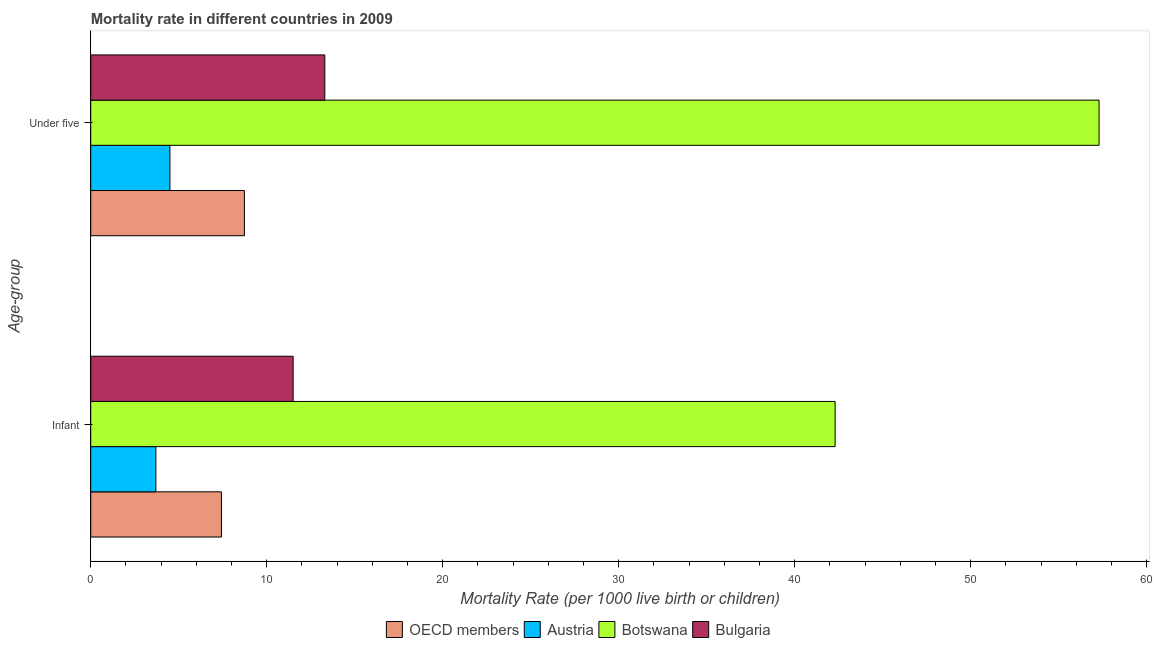Are the number of bars on each tick of the Y-axis equal?
Ensure brevity in your answer.  Yes. How many bars are there on the 2nd tick from the top?
Your response must be concise. 4. How many bars are there on the 1st tick from the bottom?
Provide a succinct answer. 4. What is the label of the 1st group of bars from the top?
Make the answer very short. Under five. Across all countries, what is the maximum under-5 mortality rate?
Give a very brief answer. 57.3. In which country was the under-5 mortality rate maximum?
Provide a succinct answer. Botswana. What is the total under-5 mortality rate in the graph?
Your answer should be compact. 83.83. What is the difference between the infant mortality rate in Austria and that in OECD members?
Make the answer very short. -3.73. What is the difference between the infant mortality rate in Bulgaria and the under-5 mortality rate in OECD members?
Provide a short and direct response. 2.77. What is the average infant mortality rate per country?
Your response must be concise. 16.23. What is the difference between the infant mortality rate and under-5 mortality rate in OECD members?
Ensure brevity in your answer.  -1.3. In how many countries, is the under-5 mortality rate greater than 34 ?
Your answer should be compact. 1. What is the ratio of the infant mortality rate in OECD members to that in Austria?
Offer a very short reply. 2.01. Is the under-5 mortality rate in Botswana less than that in OECD members?
Provide a succinct answer. No. In how many countries, is the under-5 mortality rate greater than the average under-5 mortality rate taken over all countries?
Provide a succinct answer. 1. What does the 3rd bar from the top in Infant represents?
Your answer should be compact. Austria. What does the 4th bar from the bottom in Infant represents?
Your answer should be very brief. Bulgaria. How many bars are there?
Provide a short and direct response. 8. How many countries are there in the graph?
Ensure brevity in your answer.  4. What is the difference between two consecutive major ticks on the X-axis?
Offer a very short reply. 10. Are the values on the major ticks of X-axis written in scientific E-notation?
Provide a succinct answer. No. Does the graph contain any zero values?
Your response must be concise. No. Does the graph contain grids?
Ensure brevity in your answer.  No. Where does the legend appear in the graph?
Offer a terse response. Bottom center. What is the title of the graph?
Ensure brevity in your answer.  Mortality rate in different countries in 2009. What is the label or title of the X-axis?
Make the answer very short. Mortality Rate (per 1000 live birth or children). What is the label or title of the Y-axis?
Offer a terse response. Age-group. What is the Mortality Rate (per 1000 live birth or children) of OECD members in Infant?
Give a very brief answer. 7.43. What is the Mortality Rate (per 1000 live birth or children) in Botswana in Infant?
Offer a very short reply. 42.3. What is the Mortality Rate (per 1000 live birth or children) in Bulgaria in Infant?
Your answer should be compact. 11.5. What is the Mortality Rate (per 1000 live birth or children) in OECD members in Under five?
Your answer should be compact. 8.73. What is the Mortality Rate (per 1000 live birth or children) of Austria in Under five?
Give a very brief answer. 4.5. What is the Mortality Rate (per 1000 live birth or children) in Botswana in Under five?
Your answer should be compact. 57.3. Across all Age-group, what is the maximum Mortality Rate (per 1000 live birth or children) of OECD members?
Give a very brief answer. 8.73. Across all Age-group, what is the maximum Mortality Rate (per 1000 live birth or children) of Austria?
Make the answer very short. 4.5. Across all Age-group, what is the maximum Mortality Rate (per 1000 live birth or children) in Botswana?
Offer a very short reply. 57.3. Across all Age-group, what is the minimum Mortality Rate (per 1000 live birth or children) of OECD members?
Offer a terse response. 7.43. Across all Age-group, what is the minimum Mortality Rate (per 1000 live birth or children) of Austria?
Offer a terse response. 3.7. Across all Age-group, what is the minimum Mortality Rate (per 1000 live birth or children) of Botswana?
Ensure brevity in your answer.  42.3. Across all Age-group, what is the minimum Mortality Rate (per 1000 live birth or children) of Bulgaria?
Your response must be concise. 11.5. What is the total Mortality Rate (per 1000 live birth or children) of OECD members in the graph?
Ensure brevity in your answer.  16.16. What is the total Mortality Rate (per 1000 live birth or children) in Botswana in the graph?
Give a very brief answer. 99.6. What is the total Mortality Rate (per 1000 live birth or children) of Bulgaria in the graph?
Make the answer very short. 24.8. What is the difference between the Mortality Rate (per 1000 live birth or children) of OECD members in Infant and that in Under five?
Offer a very short reply. -1.3. What is the difference between the Mortality Rate (per 1000 live birth or children) of Botswana in Infant and that in Under five?
Your answer should be compact. -15. What is the difference between the Mortality Rate (per 1000 live birth or children) in Bulgaria in Infant and that in Under five?
Keep it short and to the point. -1.8. What is the difference between the Mortality Rate (per 1000 live birth or children) of OECD members in Infant and the Mortality Rate (per 1000 live birth or children) of Austria in Under five?
Your answer should be compact. 2.93. What is the difference between the Mortality Rate (per 1000 live birth or children) of OECD members in Infant and the Mortality Rate (per 1000 live birth or children) of Botswana in Under five?
Your answer should be compact. -49.87. What is the difference between the Mortality Rate (per 1000 live birth or children) of OECD members in Infant and the Mortality Rate (per 1000 live birth or children) of Bulgaria in Under five?
Keep it short and to the point. -5.87. What is the difference between the Mortality Rate (per 1000 live birth or children) in Austria in Infant and the Mortality Rate (per 1000 live birth or children) in Botswana in Under five?
Your answer should be very brief. -53.6. What is the average Mortality Rate (per 1000 live birth or children) of OECD members per Age-group?
Your answer should be very brief. 8.08. What is the average Mortality Rate (per 1000 live birth or children) in Austria per Age-group?
Provide a short and direct response. 4.1. What is the average Mortality Rate (per 1000 live birth or children) in Botswana per Age-group?
Your response must be concise. 49.8. What is the difference between the Mortality Rate (per 1000 live birth or children) of OECD members and Mortality Rate (per 1000 live birth or children) of Austria in Infant?
Keep it short and to the point. 3.73. What is the difference between the Mortality Rate (per 1000 live birth or children) of OECD members and Mortality Rate (per 1000 live birth or children) of Botswana in Infant?
Give a very brief answer. -34.87. What is the difference between the Mortality Rate (per 1000 live birth or children) in OECD members and Mortality Rate (per 1000 live birth or children) in Bulgaria in Infant?
Your response must be concise. -4.07. What is the difference between the Mortality Rate (per 1000 live birth or children) in Austria and Mortality Rate (per 1000 live birth or children) in Botswana in Infant?
Make the answer very short. -38.6. What is the difference between the Mortality Rate (per 1000 live birth or children) of Botswana and Mortality Rate (per 1000 live birth or children) of Bulgaria in Infant?
Keep it short and to the point. 30.8. What is the difference between the Mortality Rate (per 1000 live birth or children) in OECD members and Mortality Rate (per 1000 live birth or children) in Austria in Under five?
Give a very brief answer. 4.23. What is the difference between the Mortality Rate (per 1000 live birth or children) of OECD members and Mortality Rate (per 1000 live birth or children) of Botswana in Under five?
Provide a succinct answer. -48.57. What is the difference between the Mortality Rate (per 1000 live birth or children) in OECD members and Mortality Rate (per 1000 live birth or children) in Bulgaria in Under five?
Keep it short and to the point. -4.57. What is the difference between the Mortality Rate (per 1000 live birth or children) of Austria and Mortality Rate (per 1000 live birth or children) of Botswana in Under five?
Ensure brevity in your answer.  -52.8. What is the ratio of the Mortality Rate (per 1000 live birth or children) of OECD members in Infant to that in Under five?
Make the answer very short. 0.85. What is the ratio of the Mortality Rate (per 1000 live birth or children) of Austria in Infant to that in Under five?
Offer a very short reply. 0.82. What is the ratio of the Mortality Rate (per 1000 live birth or children) in Botswana in Infant to that in Under five?
Keep it short and to the point. 0.74. What is the ratio of the Mortality Rate (per 1000 live birth or children) in Bulgaria in Infant to that in Under five?
Offer a terse response. 0.86. What is the difference between the highest and the second highest Mortality Rate (per 1000 live birth or children) in OECD members?
Make the answer very short. 1.3. What is the difference between the highest and the second highest Mortality Rate (per 1000 live birth or children) in Bulgaria?
Your answer should be compact. 1.8. What is the difference between the highest and the lowest Mortality Rate (per 1000 live birth or children) in OECD members?
Keep it short and to the point. 1.3. What is the difference between the highest and the lowest Mortality Rate (per 1000 live birth or children) of Austria?
Keep it short and to the point. 0.8. What is the difference between the highest and the lowest Mortality Rate (per 1000 live birth or children) in Botswana?
Provide a short and direct response. 15. What is the difference between the highest and the lowest Mortality Rate (per 1000 live birth or children) of Bulgaria?
Make the answer very short. 1.8. 